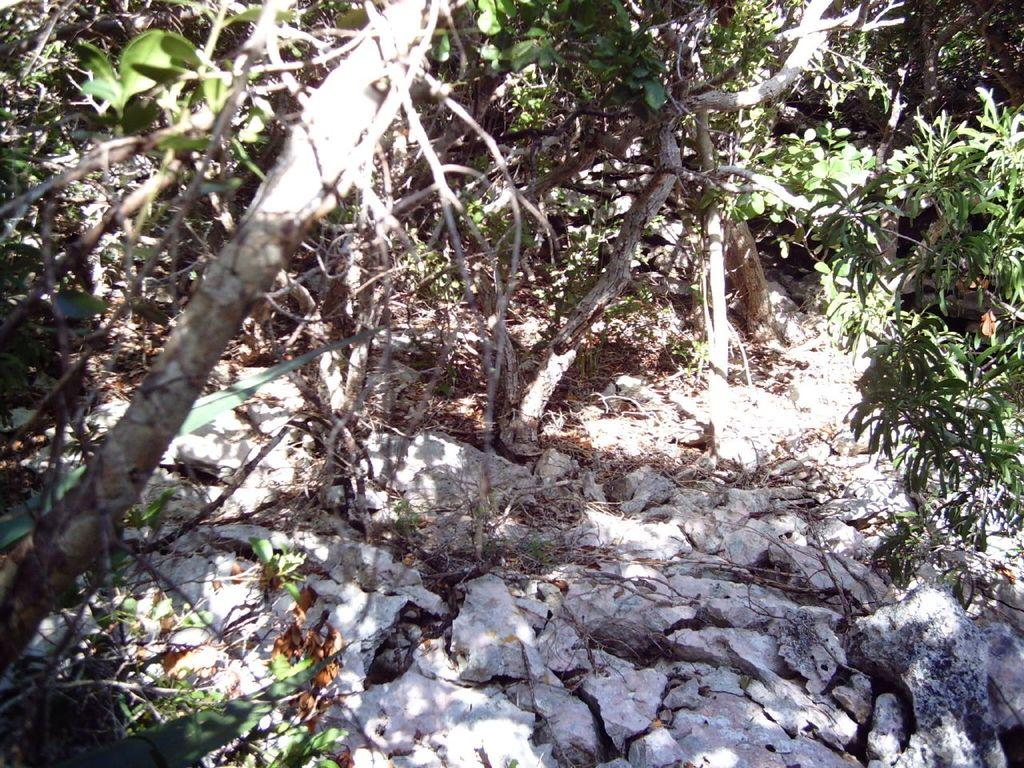What type of natural elements can be seen in the image? There are trees in the image. What can be found on the ground in the image? There are rocks on the ground in the image. Where is the zipper located in the image? There is no zipper present in the image. What type of sugar can be seen growing on the trees in the image? There is no sugar growing on the trees in the image, as trees typically do not produce sugar. 